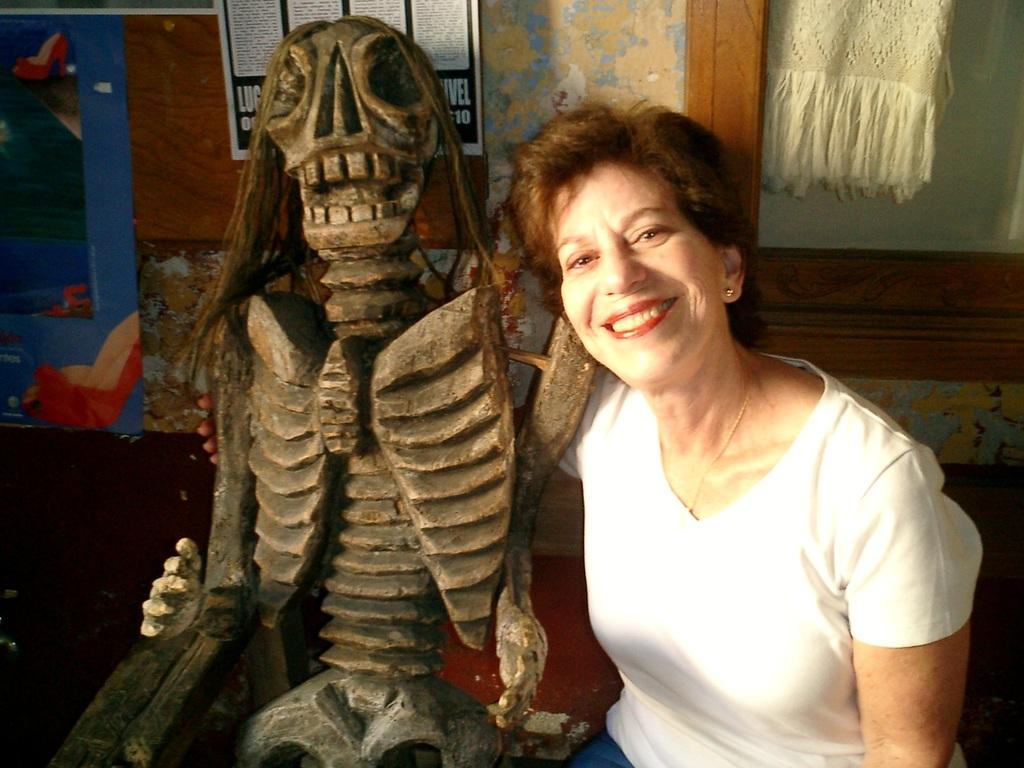What is the main subject in the image? There is a skeleton in the image. What else can be seen in the image besides the skeleton? There is a woman seated on a bench and a painting on the wall in the image. Can you describe the woman's clothing? The woman is wearing a white color t-shirt. Where is the cloth located in the image? The cloth is in a glass cupboard in the image. How many dimes are placed on the skeleton's head in the image? There are no dimes present on the skeleton's head in the image. Can you describe the bat that is flying around the woman in the image? There is no bat present in the image; the woman is seated on a bench and there is a skeleton nearby. 